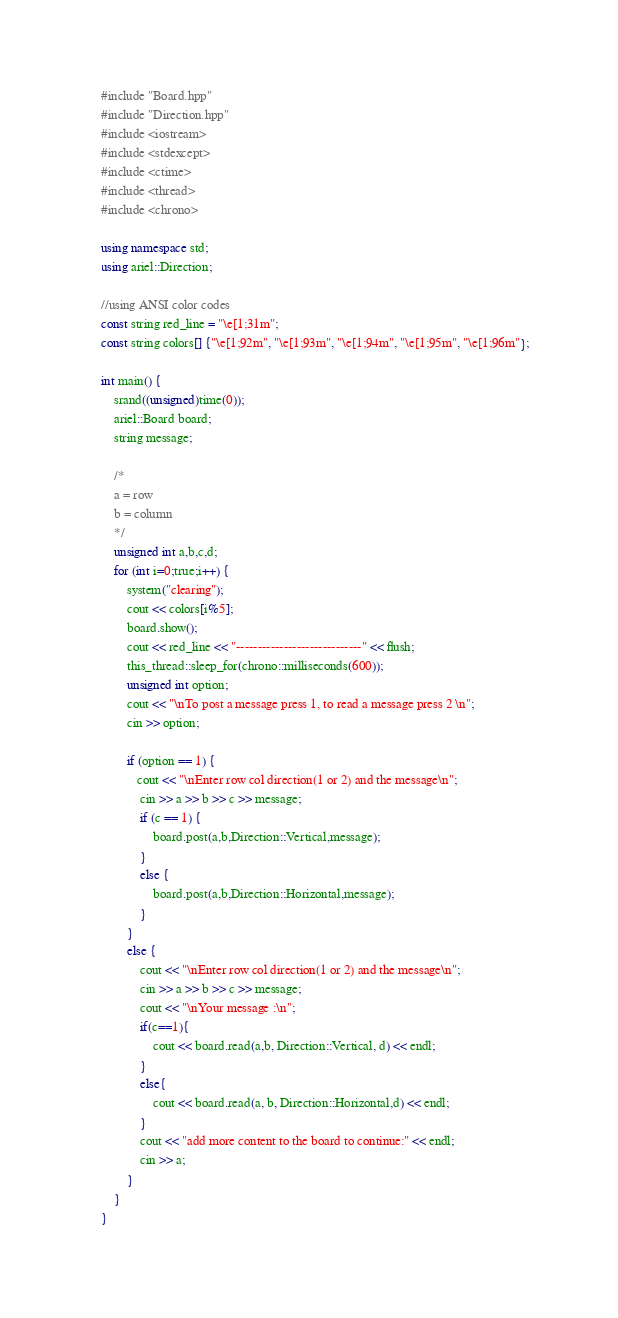Convert code to text. <code><loc_0><loc_0><loc_500><loc_500><_C++_>#include "Board.hpp"
#include "Direction.hpp"
#include <iostream>
#include <stdexcept>
#include <ctime>
#include <thread>
#include <chrono>

using namespace std;
using ariel::Direction;

//using ANSI color codes
const string red_line = "\e[1;31m"; 
const string colors[] {"\e[1;92m", "\e[1;93m", "\e[1;94m", "\e[1;95m", "\e[1;96m"};

int main() {
    srand((unsigned)time(0));
    ariel::Board board;
    string message;

    /*
    a = row
    b = column
    */
    unsigned int a,b,c,d;
    for (int i=0;true;i++) {
        system("clearing");
        cout << colors[i%5];
        board.show();
        cout << red_line << "-----------------------------" << flush;
        this_thread::sleep_for(chrono::milliseconds(600));
        unsigned int option;
        cout << "\nTo post a message press 1, to read a message press 2 \n";
        cin >> option;

        if (option == 1) {
           cout << "\nEnter row col direction(1 or 2) and the message\n";
            cin >> a >> b >> c >> message;
            if (c == 1) {
                board.post(a,b,Direction::Vertical,message);
            }
            else {
                board.post(a,b,Direction::Horizontal,message);
            }
        }
        else {
            cout << "\nEnter row col direction(1 or 2) and the message\n";
            cin >> a >> b >> c >> message;
            cout << "\nYour message :\n";
            if(c==1){
                cout << board.read(a,b, Direction::Vertical, d) << endl;
            }
            else{
                cout << board.read(a, b, Direction::Horizontal,d) << endl;
            }
            cout << "add more content to the board to continue:" << endl;
            cin >> a;
        }
    }
}
</code> 